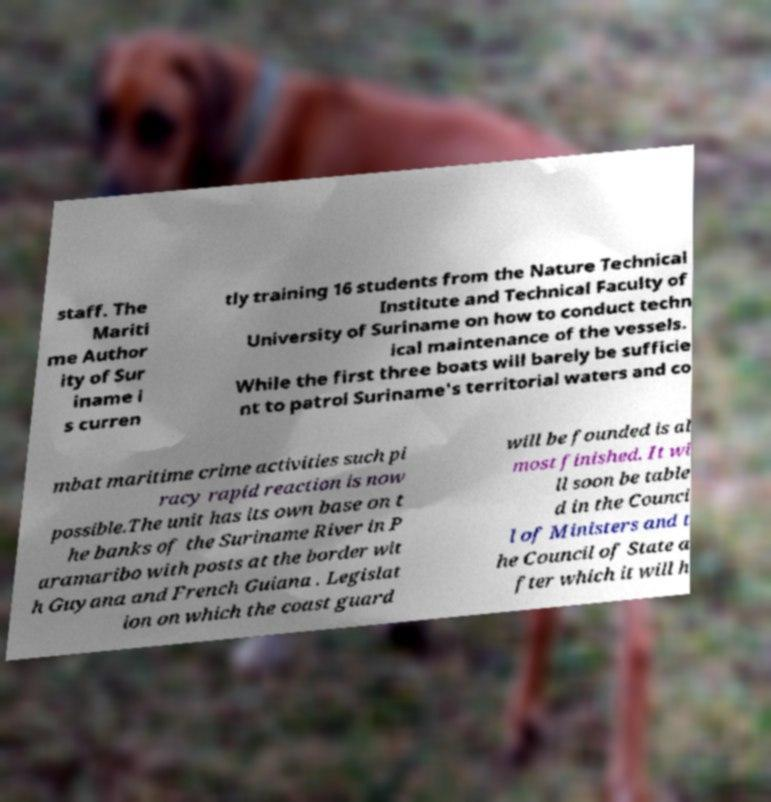What messages or text are displayed in this image? I need them in a readable, typed format. staff. The Mariti me Author ity of Sur iname i s curren tly training 16 students from the Nature Technical Institute and Technical Faculty of University of Suriname on how to conduct techn ical maintenance of the vessels. While the first three boats will barely be sufficie nt to patrol Suriname's territorial waters and co mbat maritime crime activities such pi racy rapid reaction is now possible.The unit has its own base on t he banks of the Suriname River in P aramaribo with posts at the border wit h Guyana and French Guiana . Legislat ion on which the coast guard will be founded is al most finished. It wi ll soon be table d in the Counci l of Ministers and t he Council of State a fter which it will h 